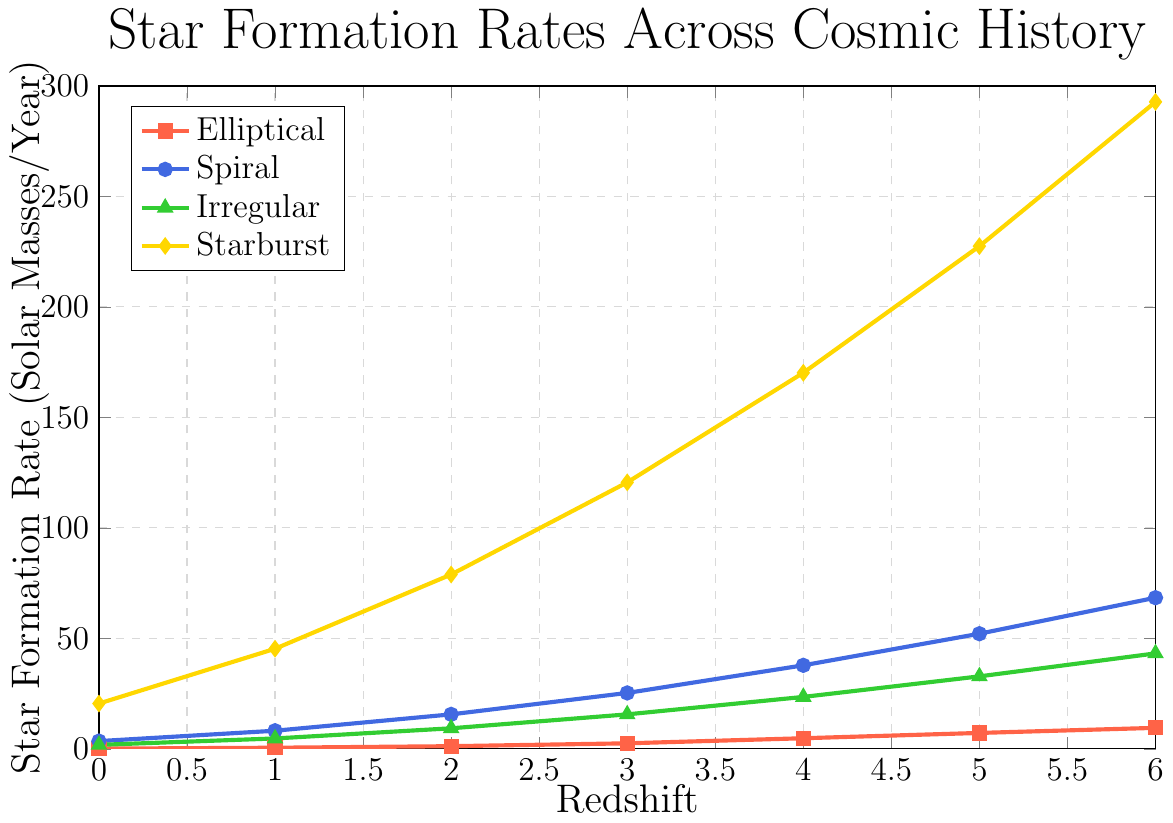Which galaxy type has the highest star formation rate at a redshift of 4? At a redshift of 4, the star formation rates of different galaxy types are: Elliptical (4.8), Spiral (37.8), Irregular (23.5), and Starburst (170.2). Starburst galaxies have the highest star formation rate.
Answer: Starburst Which galaxy type shows the least increase in star formation rate from redshift 0 to 6? To find the least increase, calculate the difference in star formation rates from redshift 0 to 6 for each galaxy type: Elliptical (9.5 - 0.1 = 9.4), Spiral (68.4 - 3.5 = 64.9), Irregular (43.2 - 1.8 = 41.4), and Starburst (292.8 - 20.5 = 272.3). Elliptical has the smallest increase.
Answer: Elliptical At which redshift does the Irregular galaxy type have the same star formation rate as the Spiral galaxy type at redshift 1? The star formation rate for the Spiral galaxy type at redshift 1 is 8.2. Checking the Irregular galaxy type, we see that its star formation rate is 9.3 at redshift 2, which is the closest match. Thus, redshift 2 is the approximate answer.
Answer: 2 How does the star formation rate for Starburst galaxies change from redshift 2 to redshift 5? Calculate the change in percentage. The star formation rate for Starburst galaxies is 78.9 at redshift 2 and 227.5 at redshift 5. The percentage change = ((227.5 - 78.9) / 78.9) * 100 = 188.3%.
Answer: 188.3% Between redshift 3 and redshift 6, which galaxy type shows the steepest increase in star formation rate? Calculate the slope (rate of change) for each galaxy type between redshift 3 and 6: Elliptical (9.5 - 2.5) / (6 - 3) = 2.33, Spiral (68.4 - 25.3) / (6 - 3) = 14.37, Irregular (43.2 - 15.6) / (6 - 3) = 9.2, and Starburst (292.8 - 120.6) / (6 - 3) = 57.4. The Starburst galaxy type shows the steepest increase.
Answer: Starburst 